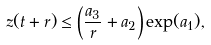Convert formula to latex. <formula><loc_0><loc_0><loc_500><loc_500>z ( t + r ) \leq \left ( \frac { a _ { 3 } } { r } + a _ { 2 } \right ) \exp ( a _ { 1 } ) ,</formula> 